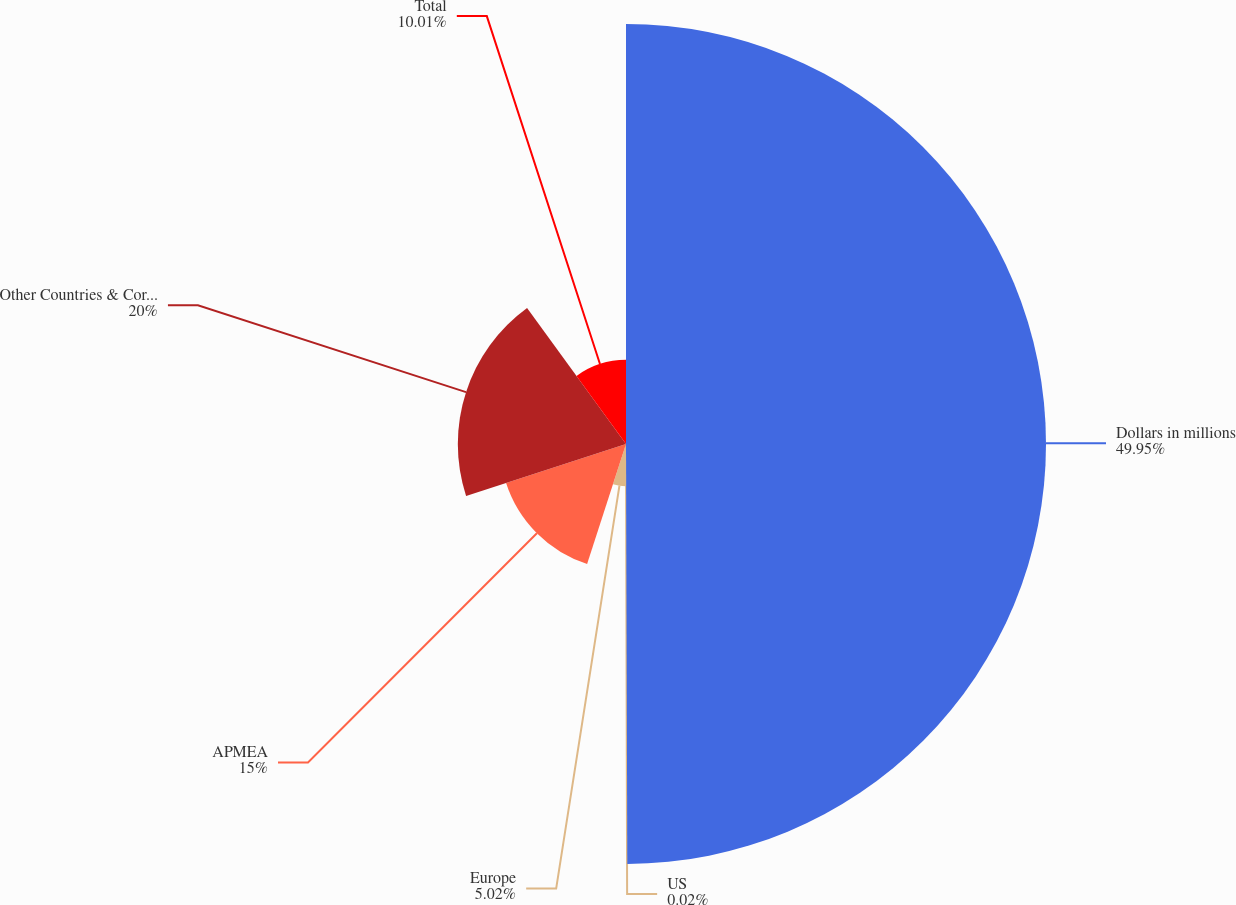<chart> <loc_0><loc_0><loc_500><loc_500><pie_chart><fcel>Dollars in millions<fcel>US<fcel>Europe<fcel>APMEA<fcel>Other Countries & Corporate<fcel>Total<nl><fcel>49.95%<fcel>0.02%<fcel>5.02%<fcel>15.0%<fcel>20.0%<fcel>10.01%<nl></chart> 